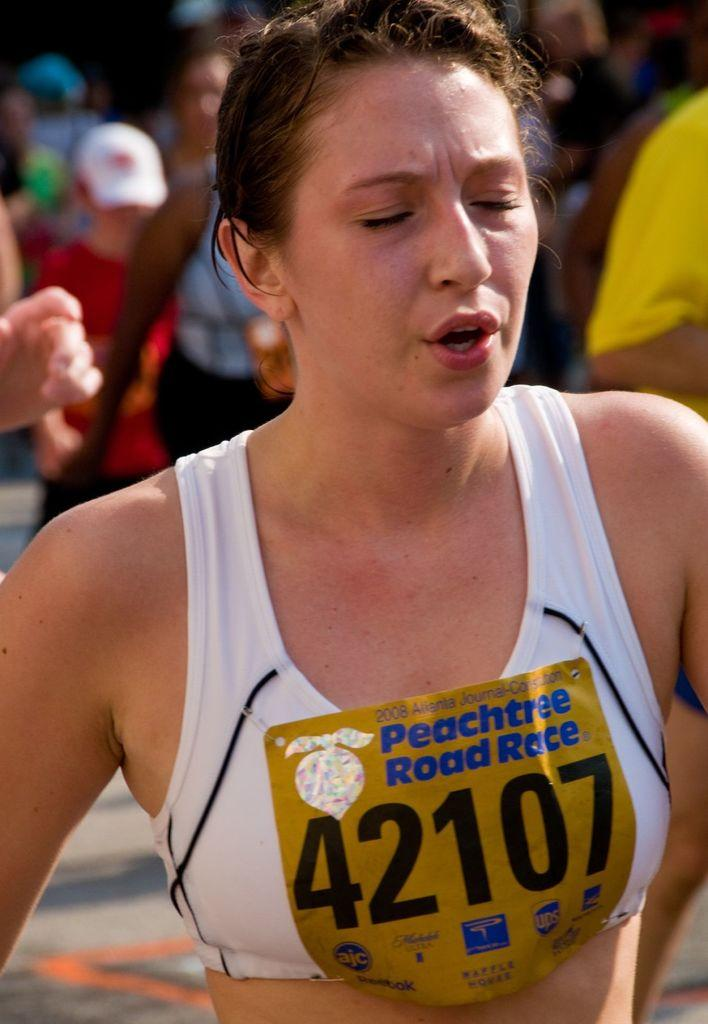<image>
Give a short and clear explanation of the subsequent image. A woman is wearing number 42107 in the peachtree road race. 